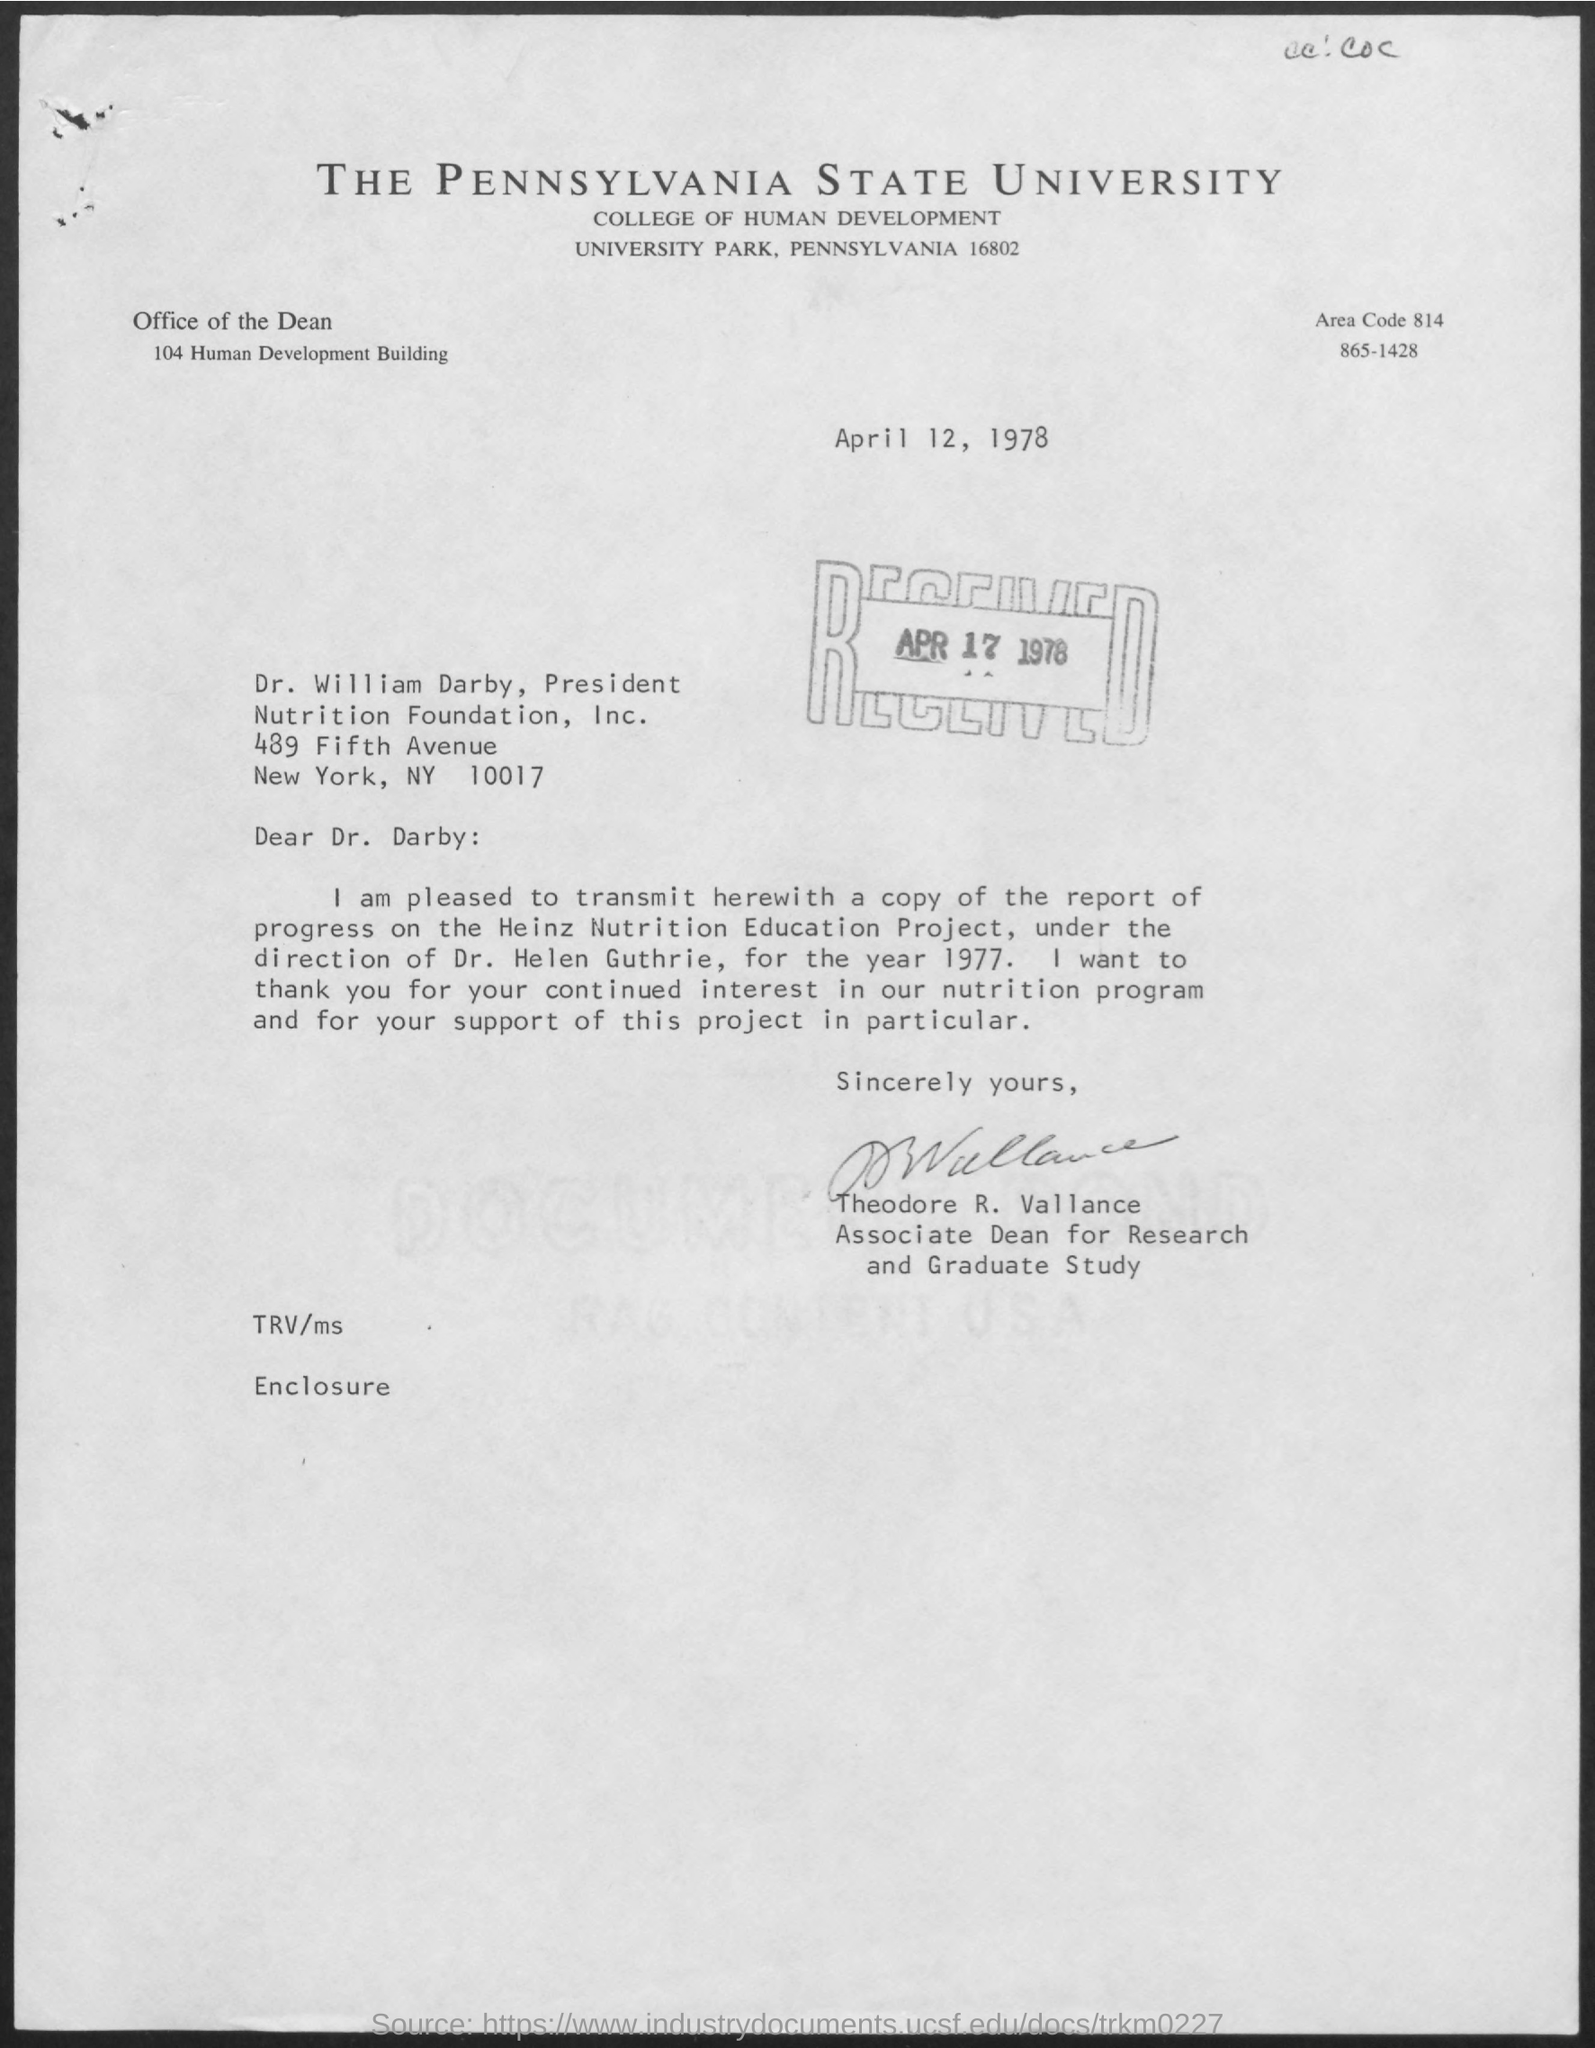Specify some key components in this picture. The letter is from Theodore R. Vallance. 